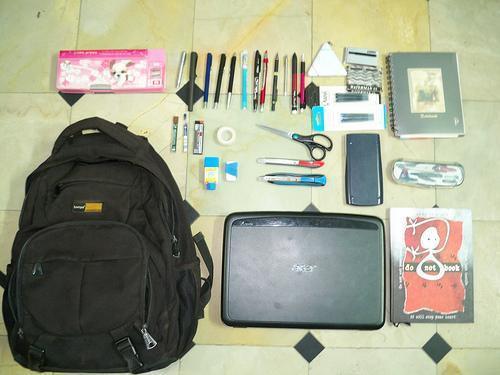How many backpacks are in the picture?
Give a very brief answer. 1. 